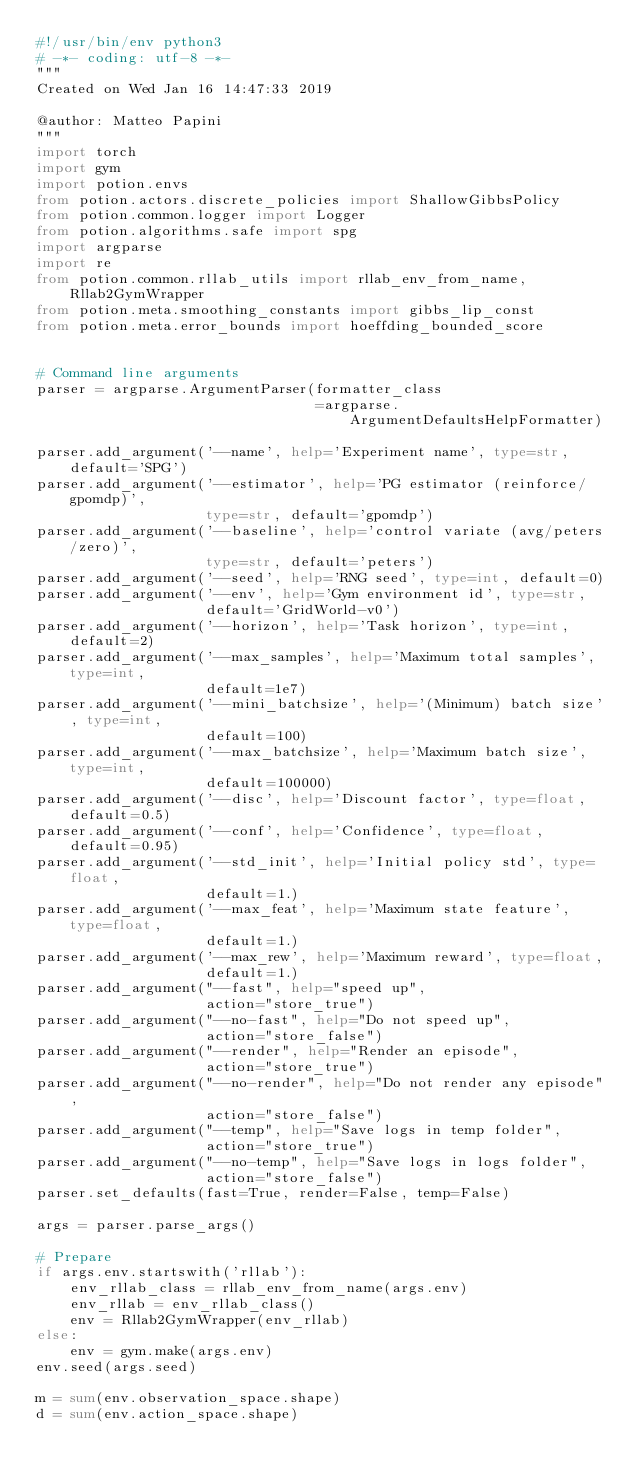<code> <loc_0><loc_0><loc_500><loc_500><_Python_>#!/usr/bin/env python3
# -*- coding: utf-8 -*-
"""
Created on Wed Jan 16 14:47:33 2019

@author: Matteo Papini
"""
import torch
import gym
import potion.envs
from potion.actors.discrete_policies import ShallowGibbsPolicy
from potion.common.logger import Logger
from potion.algorithms.safe import spg
import argparse
import re
from potion.common.rllab_utils import rllab_env_from_name, Rllab2GymWrapper
from potion.meta.smoothing_constants import gibbs_lip_const
from potion.meta.error_bounds import hoeffding_bounded_score


# Command line arguments
parser = argparse.ArgumentParser(formatter_class
                                 =argparse.ArgumentDefaultsHelpFormatter)

parser.add_argument('--name', help='Experiment name', type=str, default='SPG')
parser.add_argument('--estimator', help='PG estimator (reinforce/gpomdp)', 
                    type=str, default='gpomdp')
parser.add_argument('--baseline', help='control variate (avg/peters/zero)', 
                    type=str, default='peters')
parser.add_argument('--seed', help='RNG seed', type=int, default=0)
parser.add_argument('--env', help='Gym environment id', type=str, 
                    default='GridWorld-v0')
parser.add_argument('--horizon', help='Task horizon', type=int, default=2)
parser.add_argument('--max_samples', help='Maximum total samples', type=int, 
                    default=1e7)
parser.add_argument('--mini_batchsize', help='(Minimum) batch size', type=int, 
                    default=100)
parser.add_argument('--max_batchsize', help='Maximum batch size', type=int, 
                    default=100000)
parser.add_argument('--disc', help='Discount factor', type=float, default=0.5)
parser.add_argument('--conf', help='Confidence', type=float, default=0.95)
parser.add_argument('--std_init', help='Initial policy std', type=float, 
                    default=1.)
parser.add_argument('--max_feat', help='Maximum state feature', type=float, 
                    default=1.)
parser.add_argument('--max_rew', help='Maximum reward', type=float, 
                    default=1.)
parser.add_argument("--fast", help="speed up",
                    action="store_true")
parser.add_argument("--no-fast", help="Do not speed up",
                    action="store_false")
parser.add_argument("--render", help="Render an episode",
                    action="store_true")
parser.add_argument("--no-render", help="Do not render any episode",
                    action="store_false")
parser.add_argument("--temp", help="Save logs in temp folder",
                    action="store_true")
parser.add_argument("--no-temp", help="Save logs in logs folder",
                    action="store_false")
parser.set_defaults(fast=True, render=False, temp=False) 

args = parser.parse_args()

# Prepare
if args.env.startswith('rllab'):
    env_rllab_class = rllab_env_from_name(args.env)
    env_rllab = env_rllab_class()
    env = Rllab2GymWrapper(env_rllab)
else:
    env = gym.make(args.env)
env.seed(args.seed)

m = sum(env.observation_space.shape)
d = sum(env.action_space.shape)</code> 